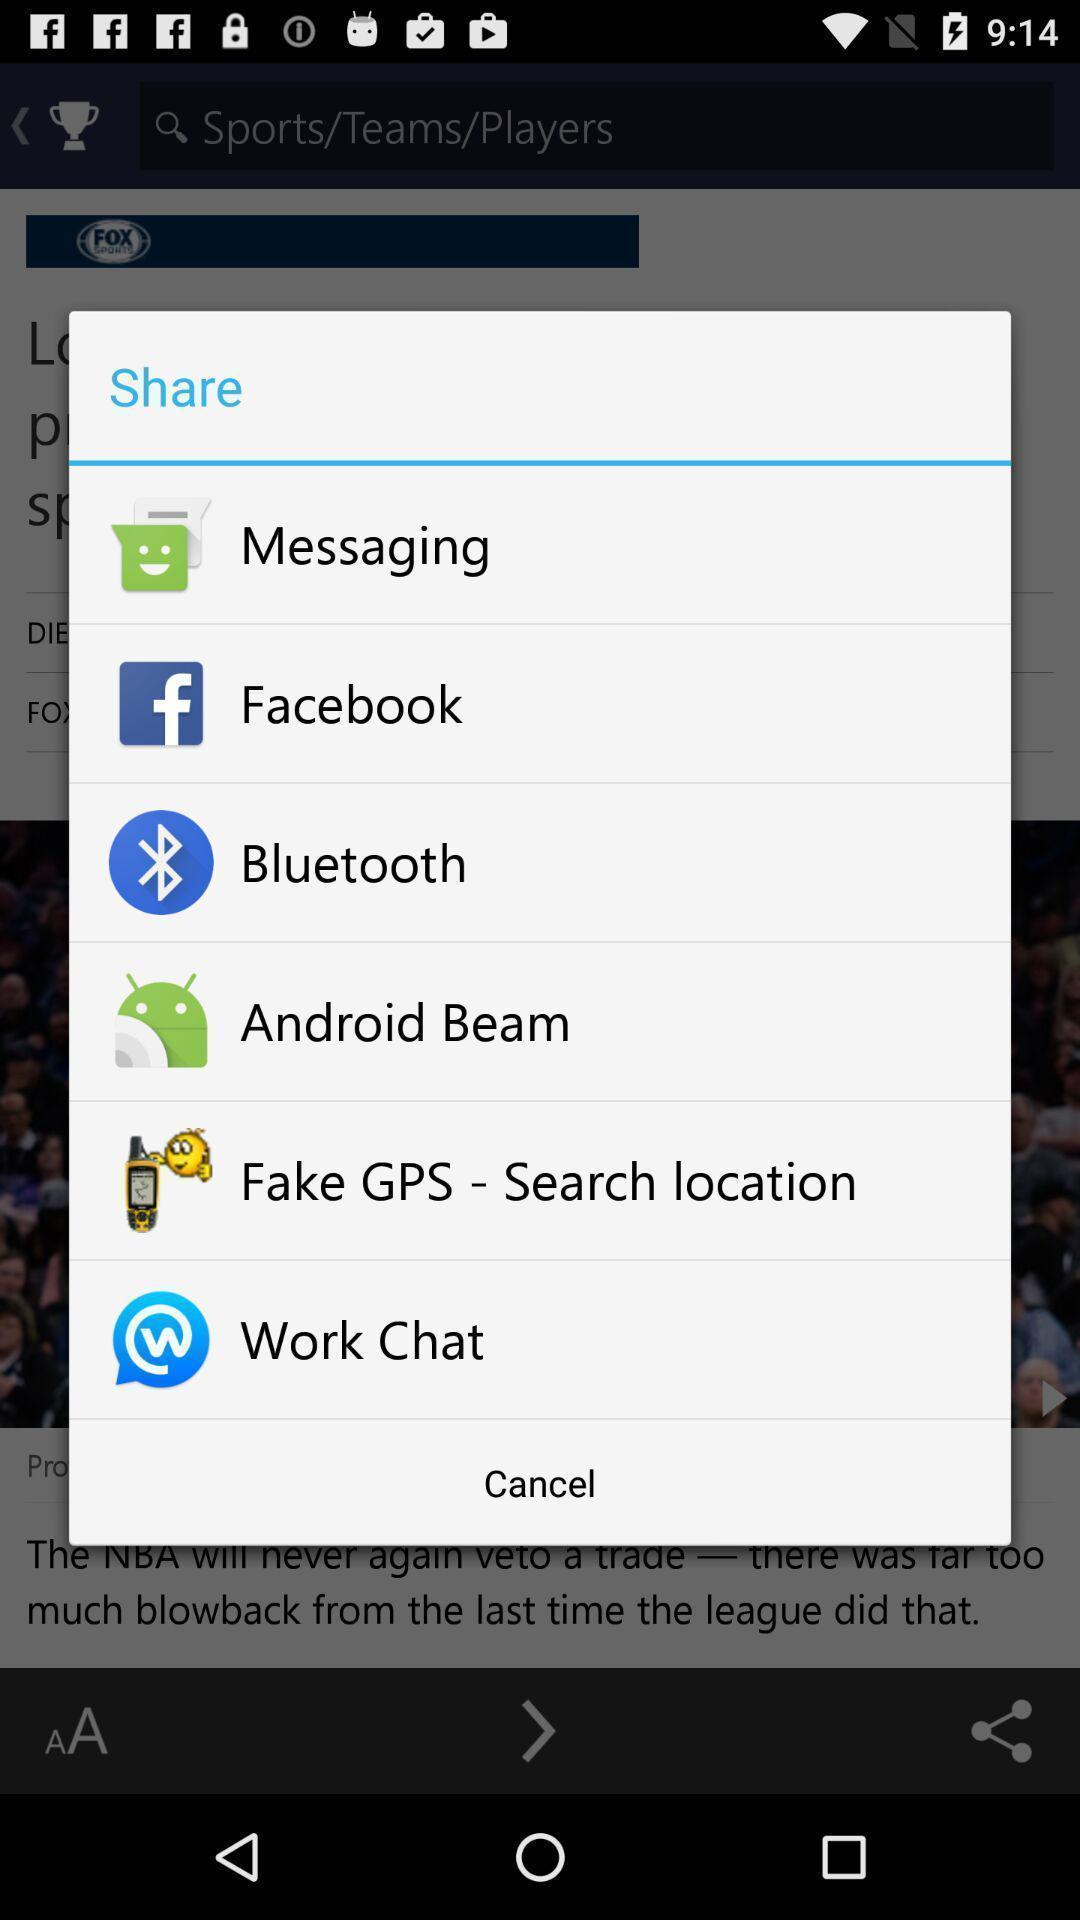What details can you identify in this image? Pop-up window displaying multiple sharing apps. 